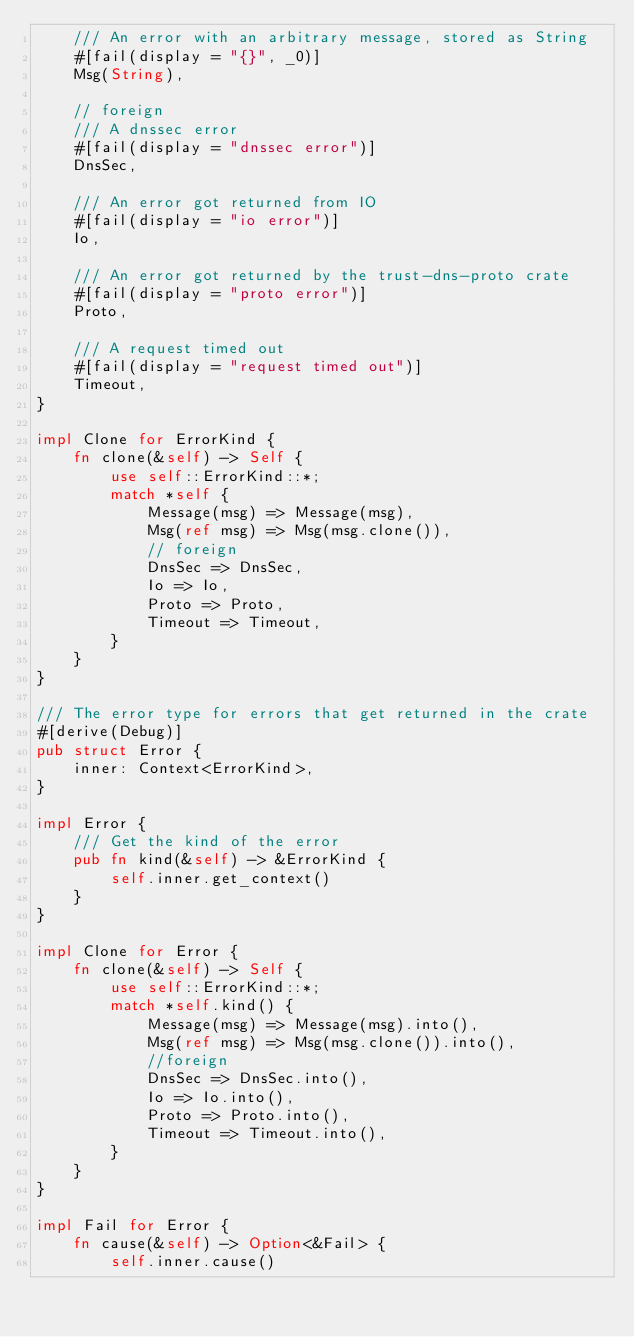<code> <loc_0><loc_0><loc_500><loc_500><_Rust_>    /// An error with an arbitrary message, stored as String
    #[fail(display = "{}", _0)]
    Msg(String),

    // foreign
    /// A dnssec error
    #[fail(display = "dnssec error")]
    DnsSec,

    /// An error got returned from IO
    #[fail(display = "io error")]
    Io,

    /// An error got returned by the trust-dns-proto crate
    #[fail(display = "proto error")]
    Proto,

    /// A request timed out
    #[fail(display = "request timed out")]
    Timeout,
}

impl Clone for ErrorKind {
    fn clone(&self) -> Self {
        use self::ErrorKind::*;
        match *self {
            Message(msg) => Message(msg),
            Msg(ref msg) => Msg(msg.clone()),
            // foreign
            DnsSec => DnsSec,
            Io => Io,
            Proto => Proto,
            Timeout => Timeout,
        }
    }
}

/// The error type for errors that get returned in the crate
#[derive(Debug)]
pub struct Error {
    inner: Context<ErrorKind>,
}

impl Error {
    /// Get the kind of the error
    pub fn kind(&self) -> &ErrorKind {
        self.inner.get_context()
    }
}

impl Clone for Error {
    fn clone(&self) -> Self {
        use self::ErrorKind::*;
        match *self.kind() {
            Message(msg) => Message(msg).into(),
            Msg(ref msg) => Msg(msg.clone()).into(),
            //foreign
            DnsSec => DnsSec.into(),
            Io => Io.into(),
            Proto => Proto.into(),
            Timeout => Timeout.into(),
        }
    }
}

impl Fail for Error {
    fn cause(&self) -> Option<&Fail> {
        self.inner.cause()</code> 